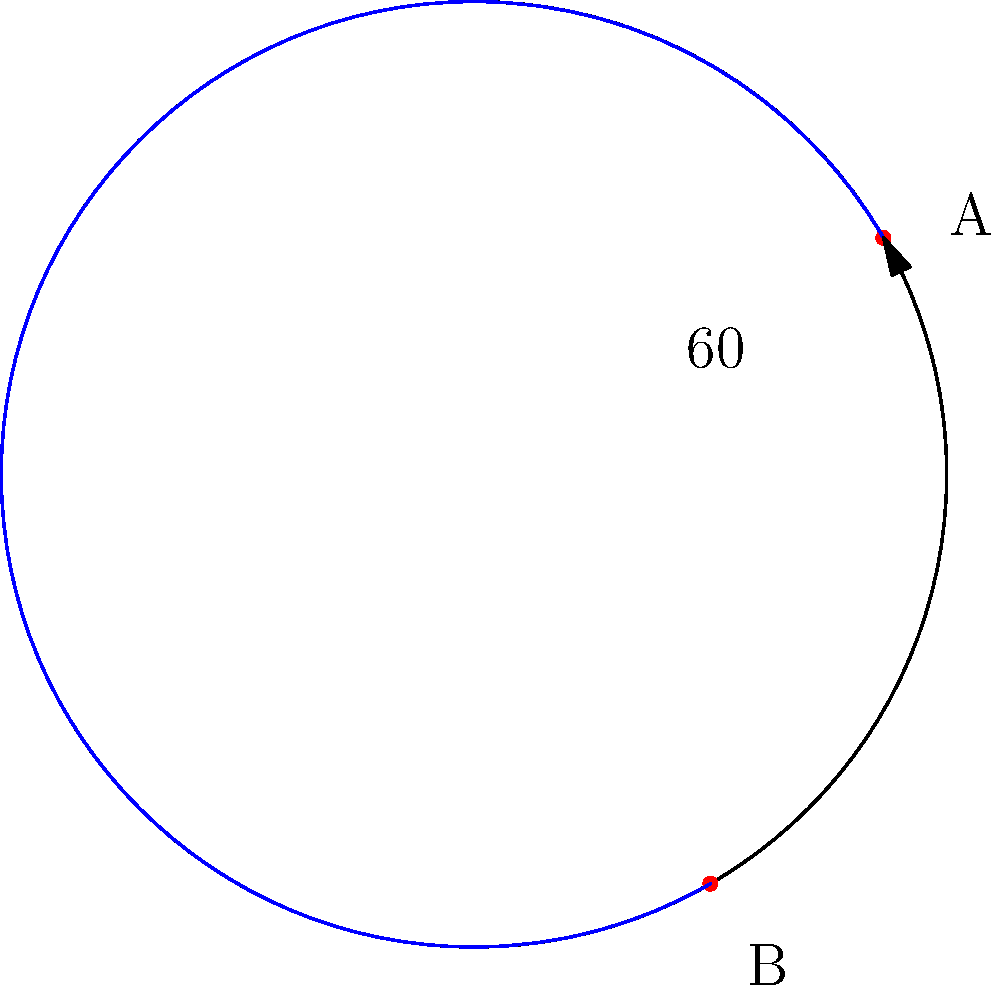Two submarine cable landing points A and B are located on the Earth's surface. Point A is at latitude 30°N and longitude 0°, while point B is at latitude 30°S and longitude 60°E. Assuming the Earth is a perfect sphere with a radius of 6371 km, calculate the shortest distance between these two points along the Earth's surface. To solve this problem, we'll use the great circle distance formula on a sphere. Here's the step-by-step solution:

1) First, we need to convert the given coordinates to radians:
   $\phi_1 = 30° \cdot \frac{\pi}{180} = \frac{\pi}{6}$ (latitude of A)
   $\lambda_1 = 0$ (longitude of A)
   $\phi_2 = -30° \cdot \frac{\pi}{180} = -\frac{\pi}{6}$ (latitude of B)
   $\lambda_2 = 60° \cdot \frac{\pi}{180} = \frac{\pi}{3}$ (longitude of B)

2) Now we can use the great circle distance formula:
   $\cos(\Delta\sigma) = \sin(\phi_1)\sin(\phi_2) + \cos(\phi_1)\cos(\phi_2)\cos(\Delta\lambda)$

   Where $\Delta\sigma$ is the central angle between the points and $\Delta\lambda = |\lambda_1 - \lambda_2|$

3) Let's calculate each part:
   $\sin(\phi_1)\sin(\phi_2) = \sin(\frac{\pi}{6})\sin(-\frac{\pi}{6}) = -\frac{1}{4}$
   $\cos(\phi_1)\cos(\phi_2) = \cos(\frac{\pi}{6})\cos(-\frac{\pi}{6}) = \frac{3}{4}$
   $\cos(\Delta\lambda) = \cos(\frac{\pi}{3}) = \frac{1}{2}$

4) Substituting these values:
   $\cos(\Delta\sigma) = -\frac{1}{4} + \frac{3}{4} \cdot \frac{1}{2} = \frac{1}{8}$

5) Taking the inverse cosine:
   $\Delta\sigma = \arccos(\frac{1}{8}) \approx 1.4454$ radians

6) The distance $d$ is then:
   $d = R \cdot \Delta\sigma$
   Where $R$ is the Earth's radius (6371 km)

7) Therefore:
   $d = 6371 \cdot 1.4454 \approx 9208.9$ km

Thus, the shortest distance between the two points along the Earth's surface is approximately 9208.9 km.
Answer: 9208.9 km 